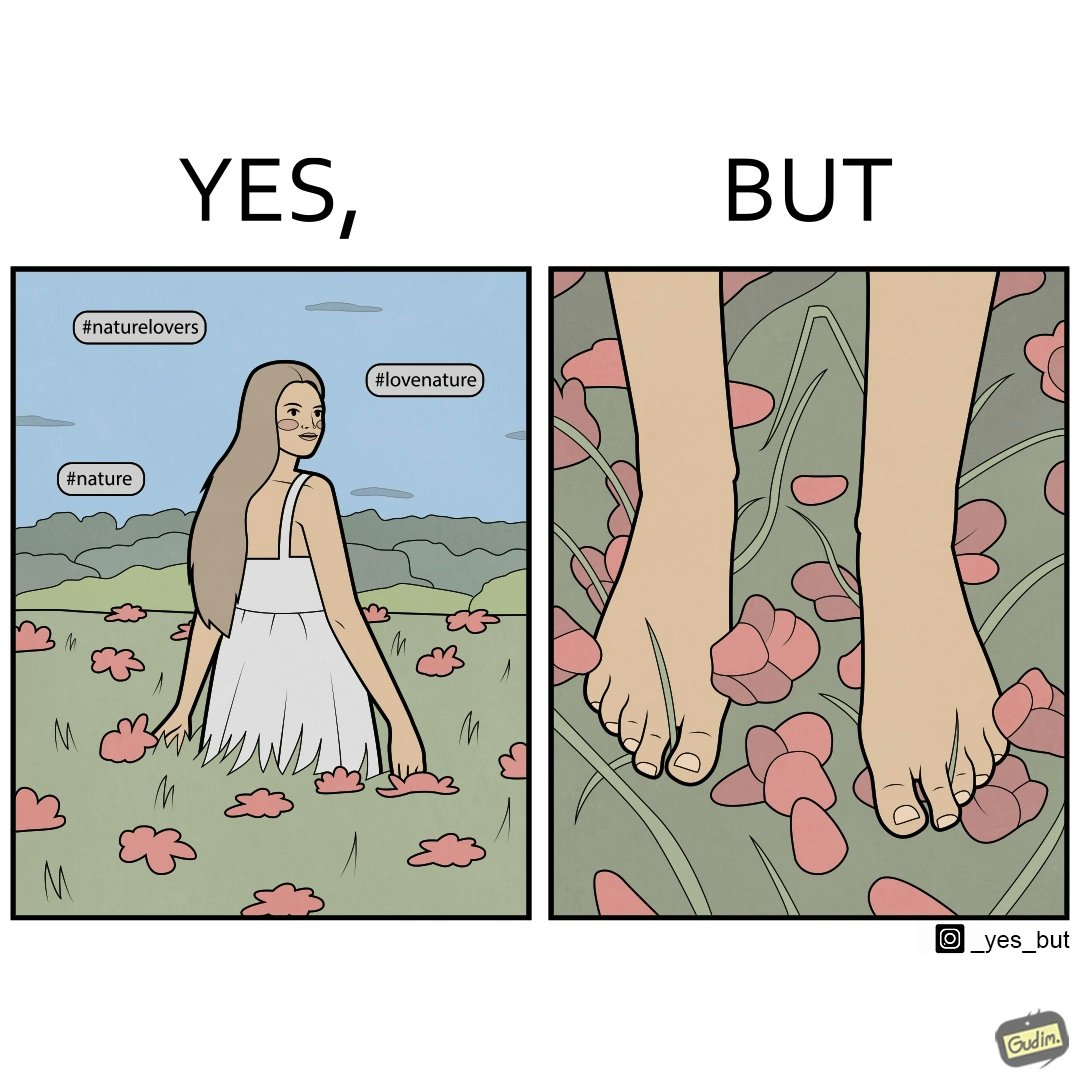Is this a satirical image? Yes, this image is satirical. 